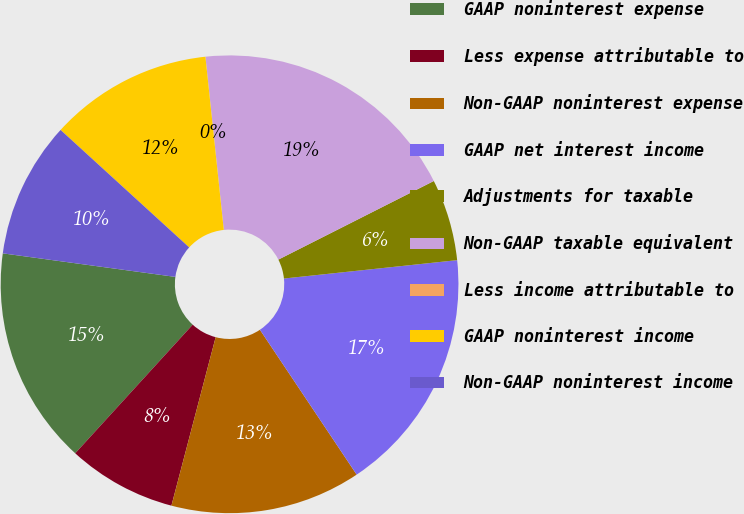Convert chart. <chart><loc_0><loc_0><loc_500><loc_500><pie_chart><fcel>GAAP noninterest expense<fcel>Less expense attributable to<fcel>Non-GAAP noninterest expense<fcel>GAAP net interest income<fcel>Adjustments for taxable<fcel>Non-GAAP taxable equivalent<fcel>Less income attributable to<fcel>GAAP noninterest income<fcel>Non-GAAP noninterest income<nl><fcel>15.38%<fcel>7.69%<fcel>13.46%<fcel>17.31%<fcel>5.77%<fcel>19.23%<fcel>0.0%<fcel>11.54%<fcel>9.62%<nl></chart> 